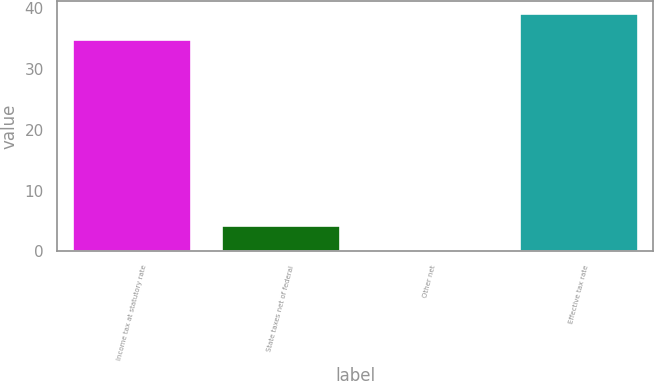<chart> <loc_0><loc_0><loc_500><loc_500><bar_chart><fcel>Income tax at statutory rate<fcel>State taxes net of federal<fcel>Other net<fcel>Effective tax rate<nl><fcel>35<fcel>4.28<fcel>0.4<fcel>39.2<nl></chart> 